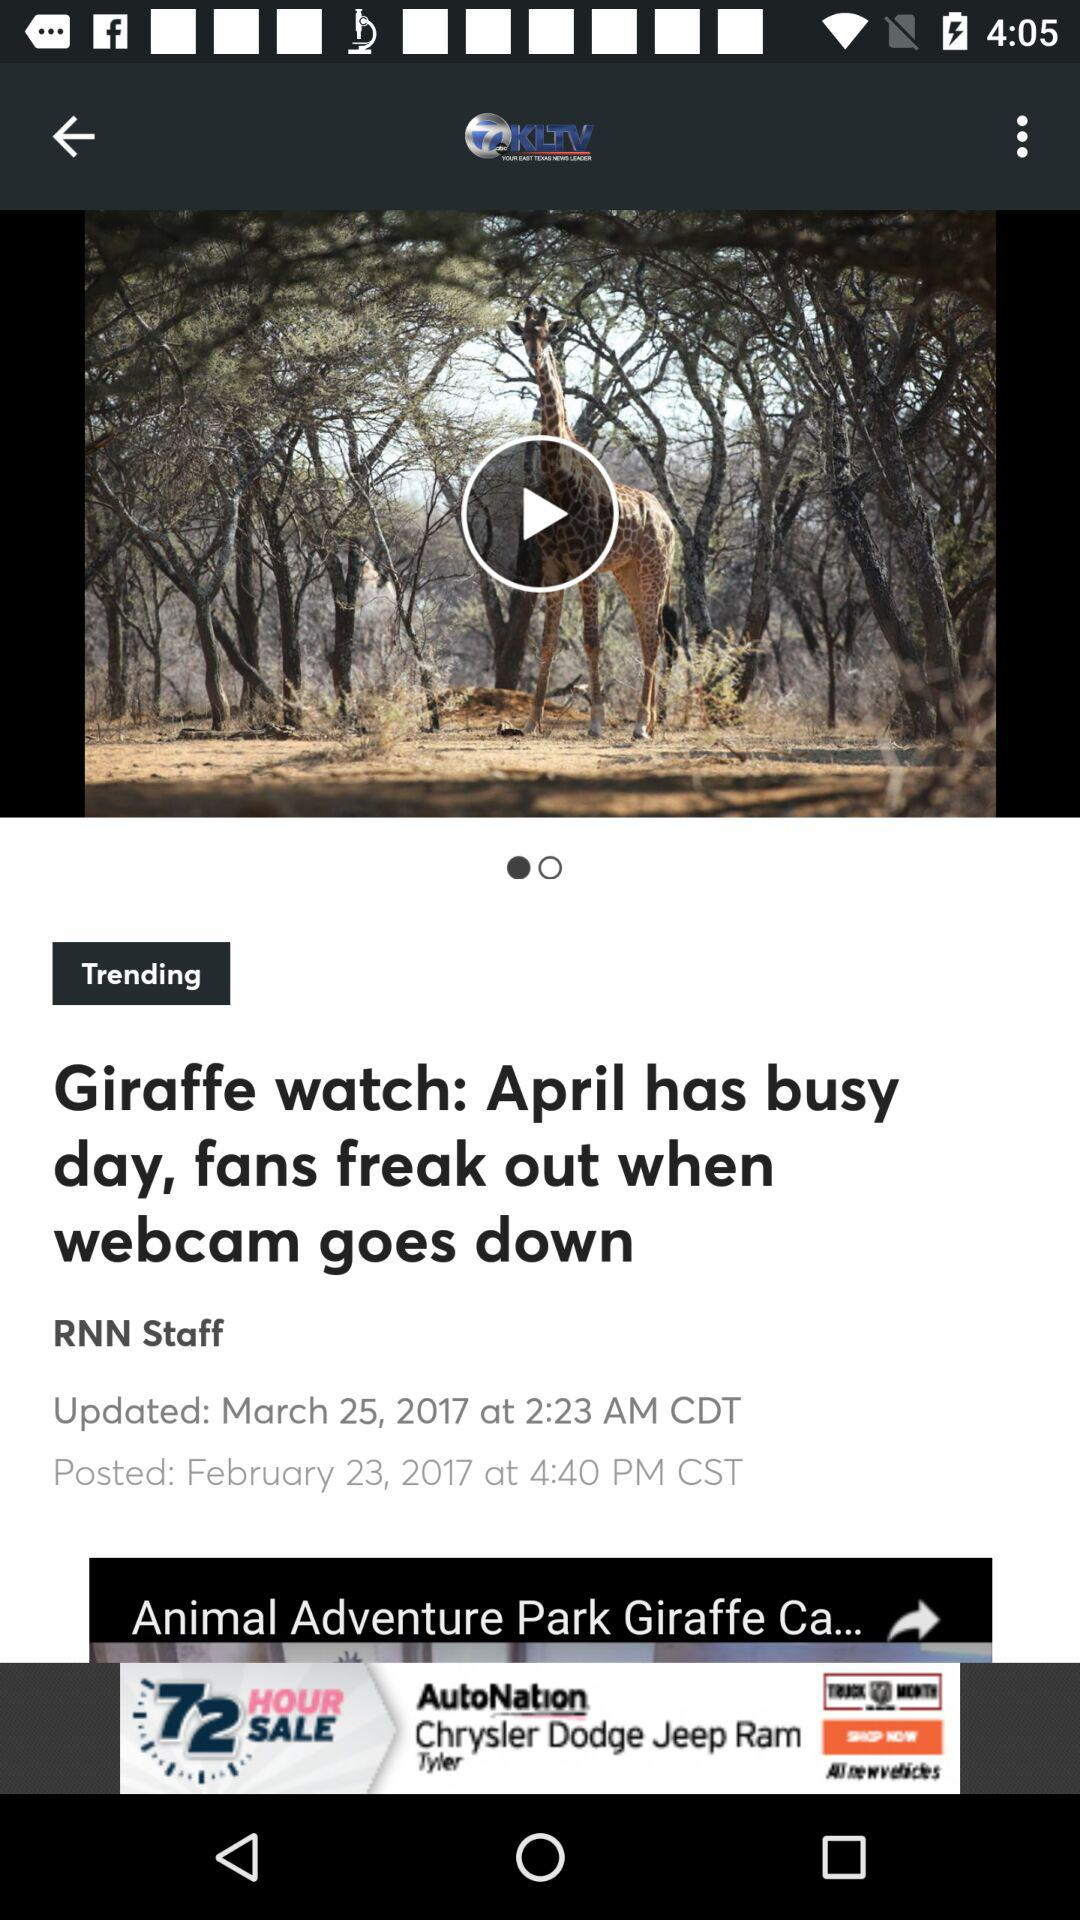For how long will this video be trending?
When the provided information is insufficient, respond with <no answer>. <no answer> 